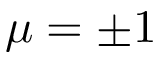Convert formula to latex. <formula><loc_0><loc_0><loc_500><loc_500>\mu = \pm 1</formula> 